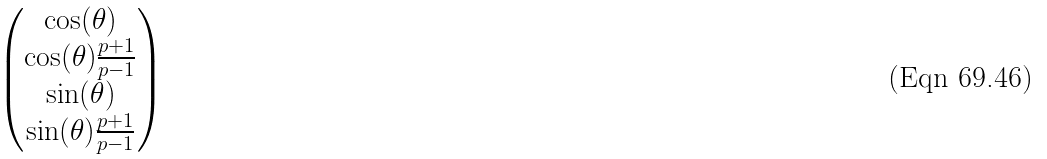Convert formula to latex. <formula><loc_0><loc_0><loc_500><loc_500>\begin{pmatrix} \cos ( \theta ) \\ \cos ( \theta ) \frac { p + 1 } { p - 1 } \\ \sin ( \theta ) \\ \sin ( \theta ) \frac { p + 1 } { p - 1 } \end{pmatrix}</formula> 